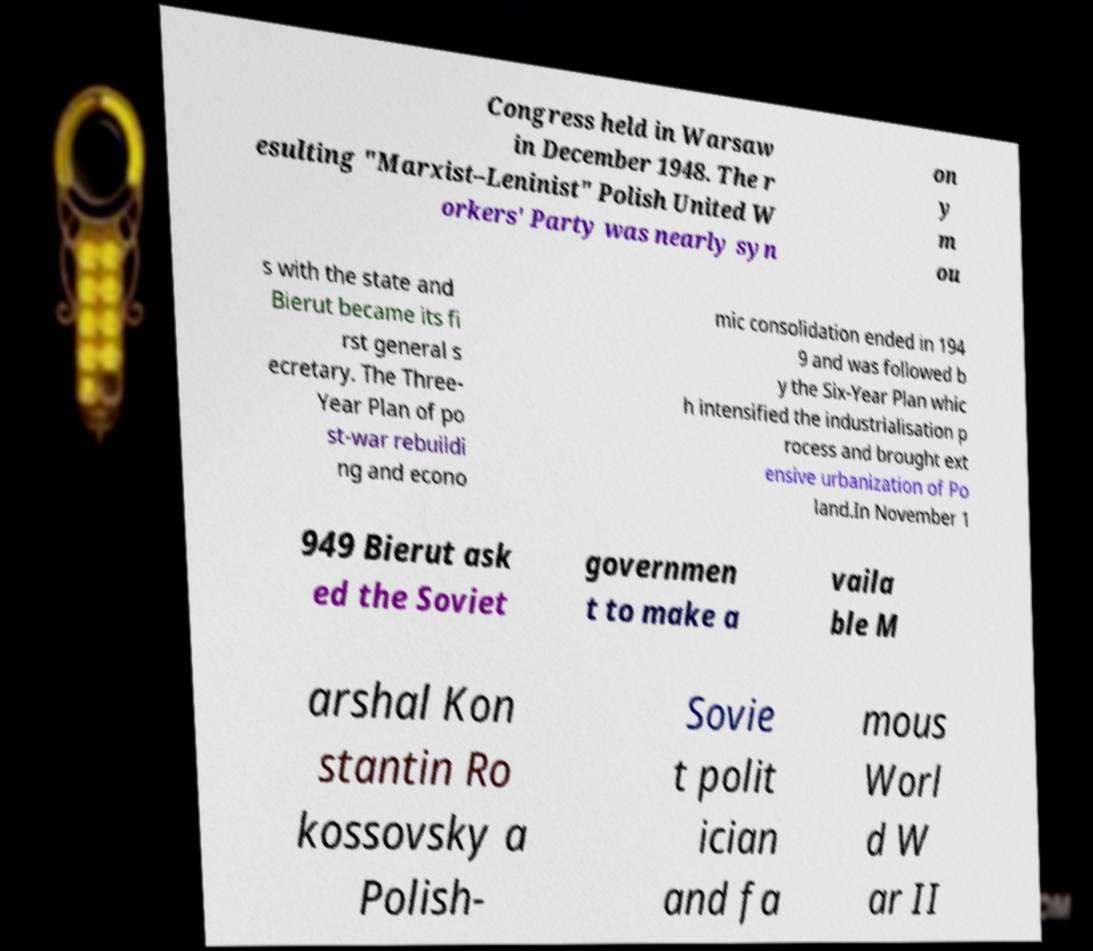Please read and relay the text visible in this image. What does it say? Congress held in Warsaw in December 1948. The r esulting "Marxist–Leninist" Polish United W orkers' Party was nearly syn on y m ou s with the state and Bierut became its fi rst general s ecretary. The Three- Year Plan of po st-war rebuildi ng and econo mic consolidation ended in 194 9 and was followed b y the Six-Year Plan whic h intensified the industrialisation p rocess and brought ext ensive urbanization of Po land.In November 1 949 Bierut ask ed the Soviet governmen t to make a vaila ble M arshal Kon stantin Ro kossovsky a Polish- Sovie t polit ician and fa mous Worl d W ar II 